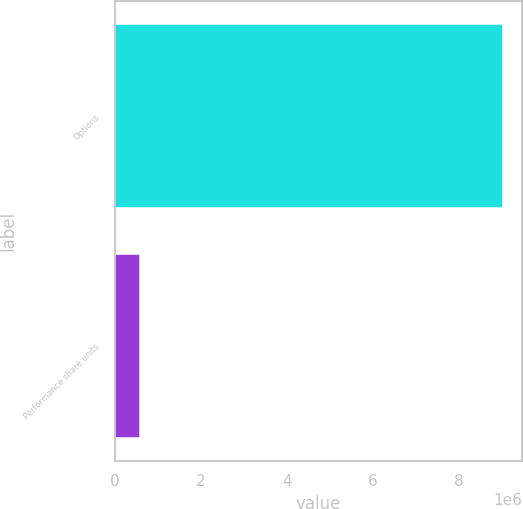Convert chart to OTSL. <chart><loc_0><loc_0><loc_500><loc_500><bar_chart><fcel>Options<fcel>Performance share units<nl><fcel>9.02364e+06<fcel>589029<nl></chart> 